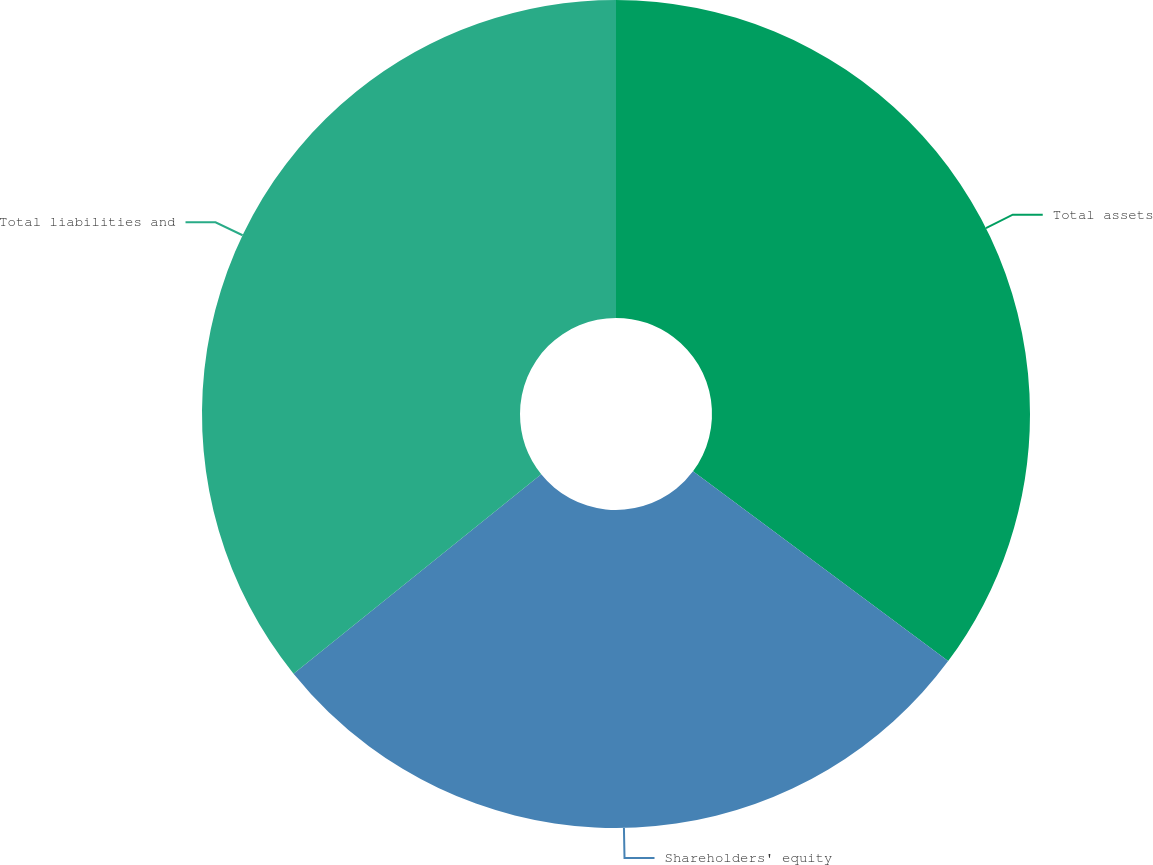Convert chart to OTSL. <chart><loc_0><loc_0><loc_500><loc_500><pie_chart><fcel>Total assets<fcel>Shareholders' equity<fcel>Total liabilities and<nl><fcel>35.18%<fcel>29.03%<fcel>35.79%<nl></chart> 